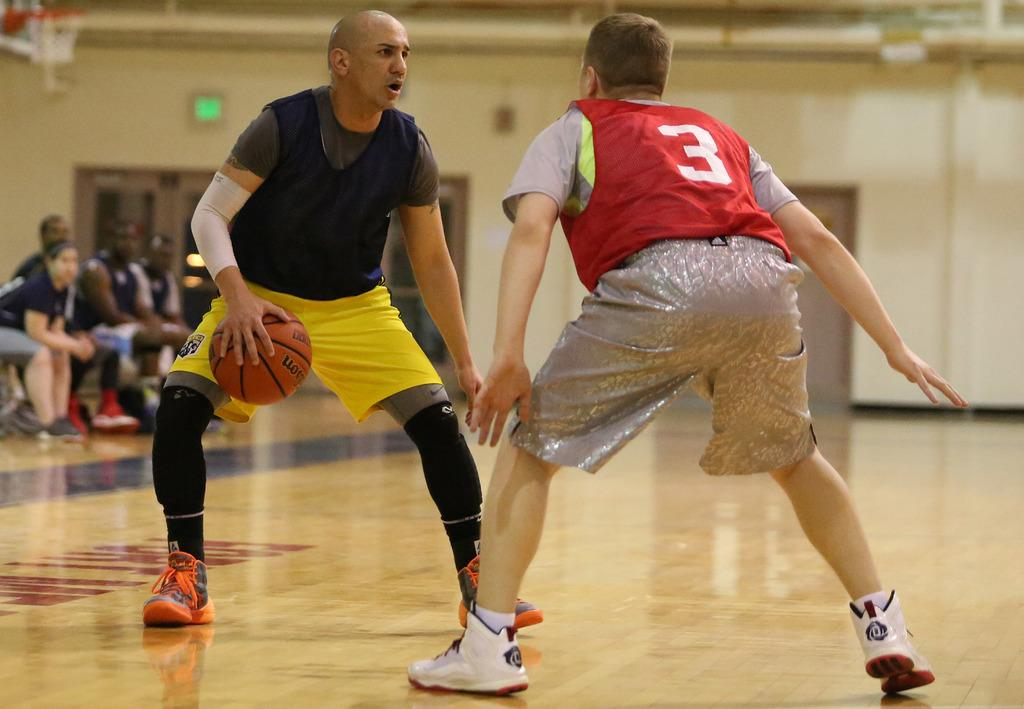What are the two persons in the image doing? The two persons in the image are playing. What type of clothing are the persons wearing? The persons are wearing jerseys. Can you describe the people in the background of the image? There are people sitting in the background of the image. What is visible in the image besides the persons playing? There is a wall visible in the image. How many lizards can be seen crawling on the wall in the image? There are no lizards visible in the image; only the persons playing, their clothing, the people sitting in the background, and the wall are present. What type of jelly is being used as a prop in the image? There is no jelly present in the image. 